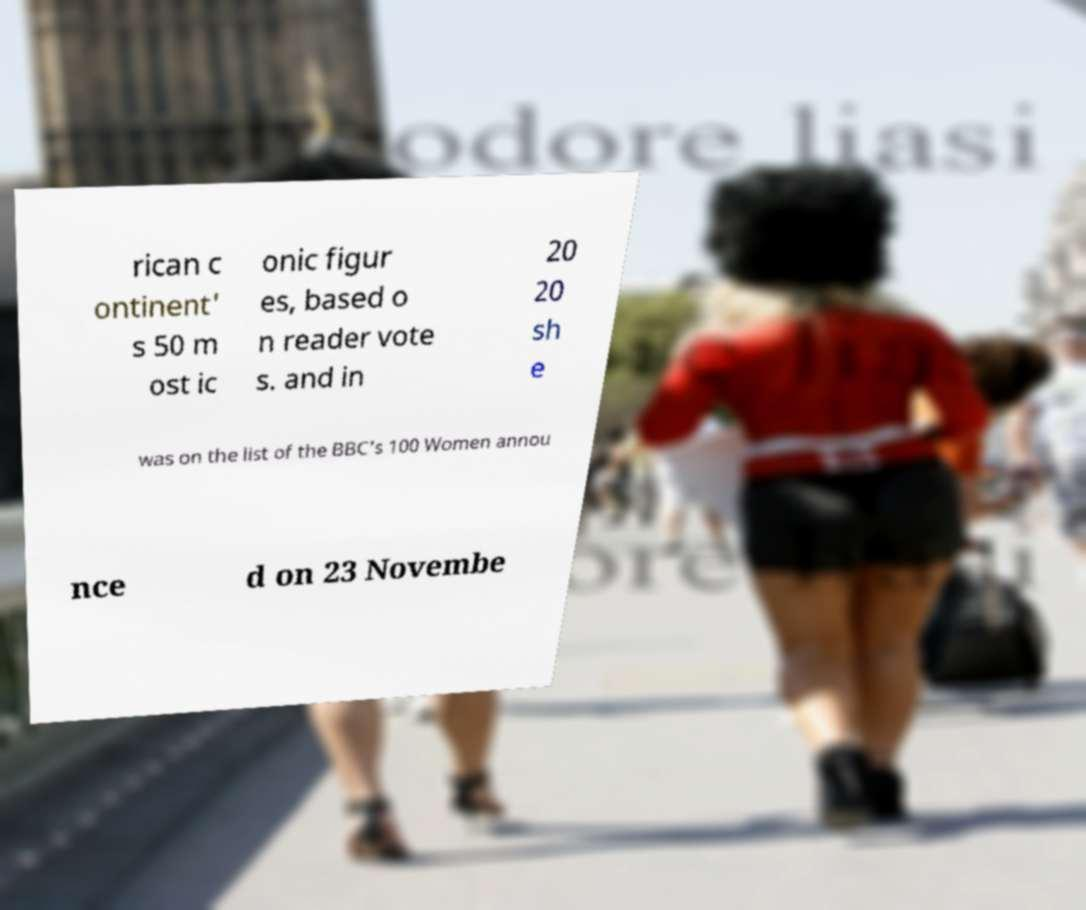Please identify and transcribe the text found in this image. rican c ontinent' s 50 m ost ic onic figur es, based o n reader vote s. and in 20 20 sh e was on the list of the BBC's 100 Women annou nce d on 23 Novembe 